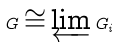Convert formula to latex. <formula><loc_0><loc_0><loc_500><loc_500>G \cong \varprojlim G _ { i }</formula> 